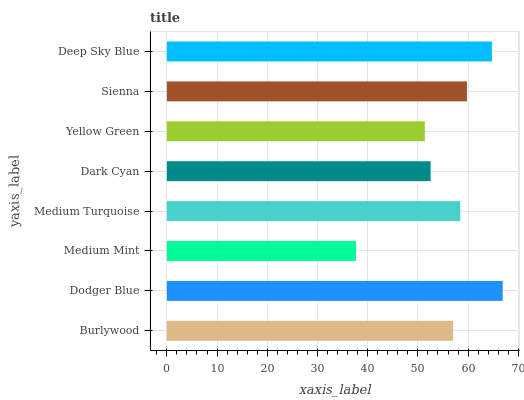Is Medium Mint the minimum?
Answer yes or no. Yes. Is Dodger Blue the maximum?
Answer yes or no. Yes. Is Dodger Blue the minimum?
Answer yes or no. No. Is Medium Mint the maximum?
Answer yes or no. No. Is Dodger Blue greater than Medium Mint?
Answer yes or no. Yes. Is Medium Mint less than Dodger Blue?
Answer yes or no. Yes. Is Medium Mint greater than Dodger Blue?
Answer yes or no. No. Is Dodger Blue less than Medium Mint?
Answer yes or no. No. Is Medium Turquoise the high median?
Answer yes or no. Yes. Is Burlywood the low median?
Answer yes or no. Yes. Is Medium Mint the high median?
Answer yes or no. No. Is Yellow Green the low median?
Answer yes or no. No. 